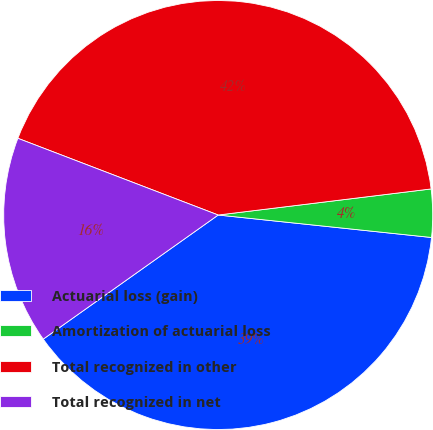<chart> <loc_0><loc_0><loc_500><loc_500><pie_chart><fcel>Actuarial loss (gain)<fcel>Amortization of actuarial loss<fcel>Total recognized in other<fcel>Total recognized in net<nl><fcel>38.51%<fcel>3.61%<fcel>42.24%<fcel>15.64%<nl></chart> 